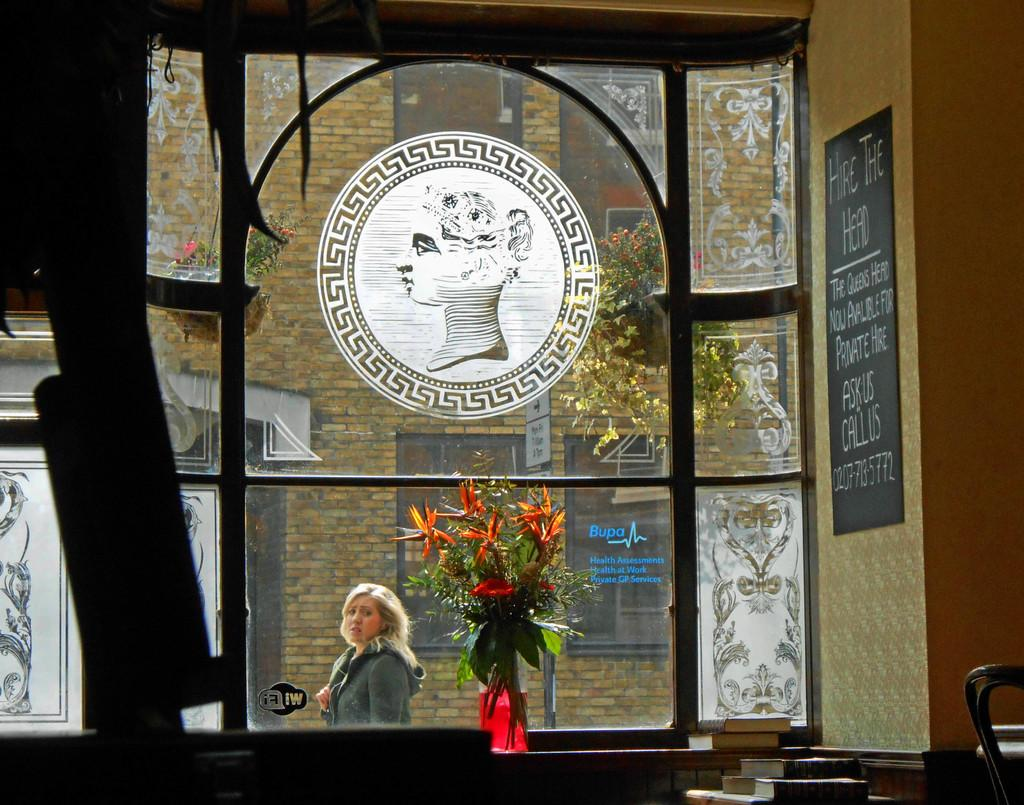Provide a one-sentence caption for the provided image. Person standing in front of a window that says BUPA on it. 